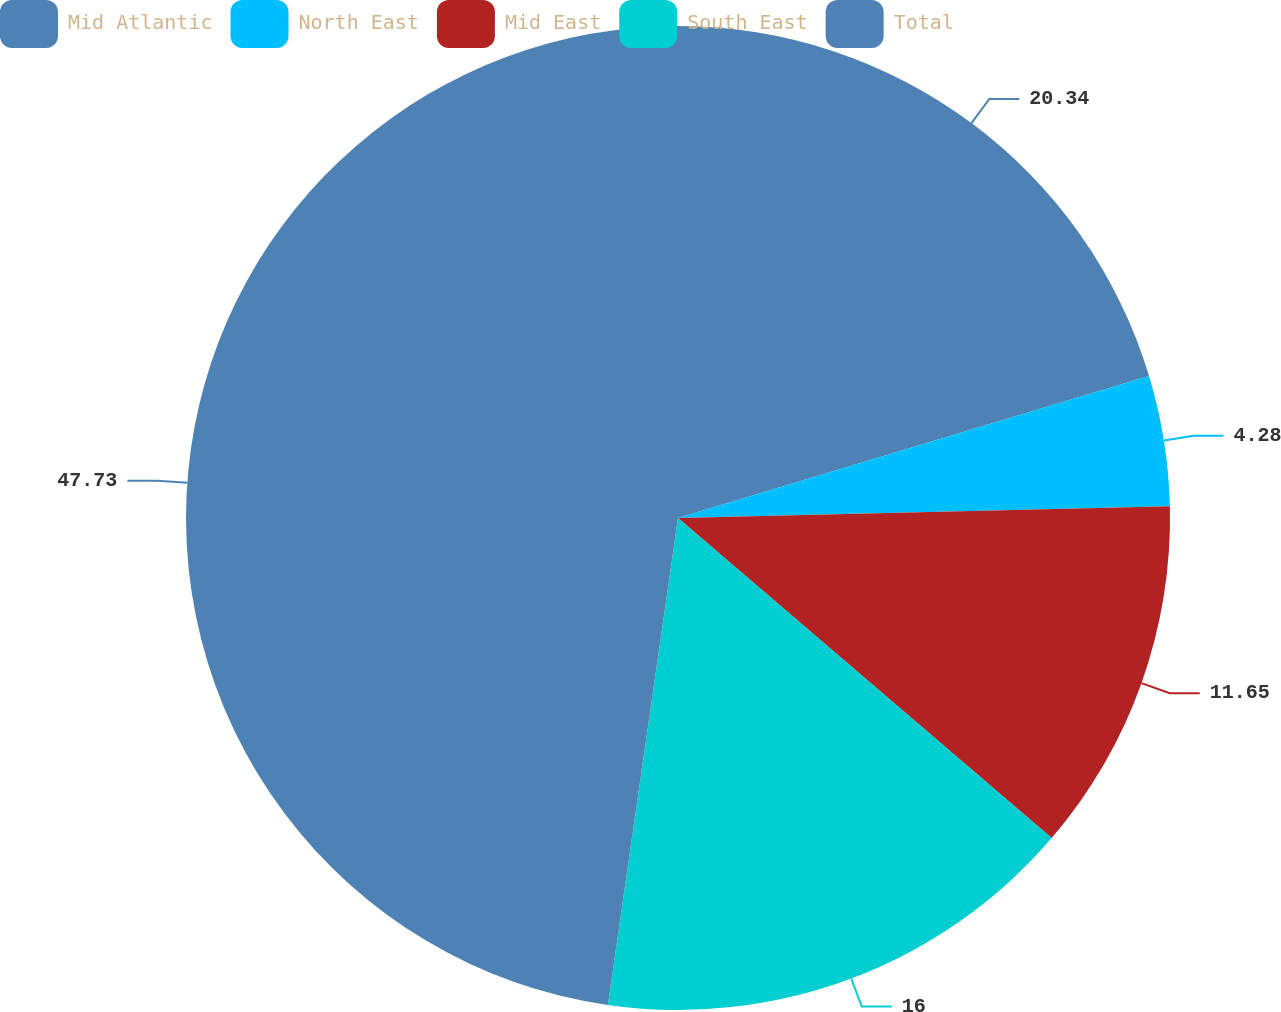Convert chart. <chart><loc_0><loc_0><loc_500><loc_500><pie_chart><fcel>Mid Atlantic<fcel>North East<fcel>Mid East<fcel>South East<fcel>Total<nl><fcel>20.34%<fcel>4.28%<fcel>11.65%<fcel>16.0%<fcel>47.72%<nl></chart> 